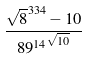<formula> <loc_0><loc_0><loc_500><loc_500>\frac { \sqrt { 8 } ^ { 3 3 4 } - 1 0 } { { 8 9 ^ { 1 4 } } ^ { \sqrt { 1 0 } } }</formula> 